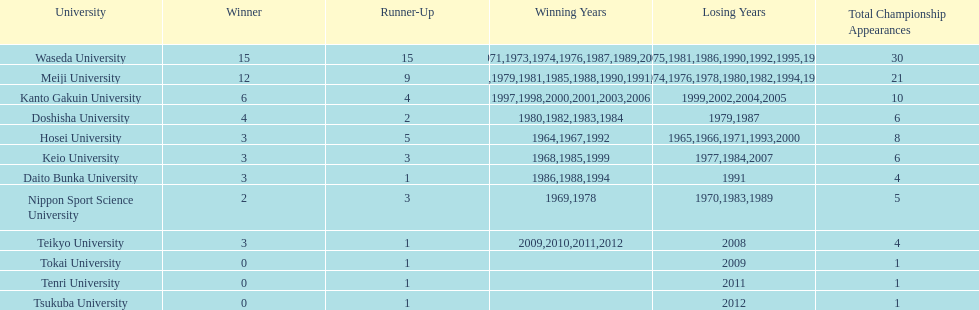Which universities had a number of wins higher than 12? Waseda University. 